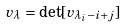Convert formula to latex. <formula><loc_0><loc_0><loc_500><loc_500>v _ { \lambda } = \det [ v _ { \lambda _ { i } - i + j } ]</formula> 